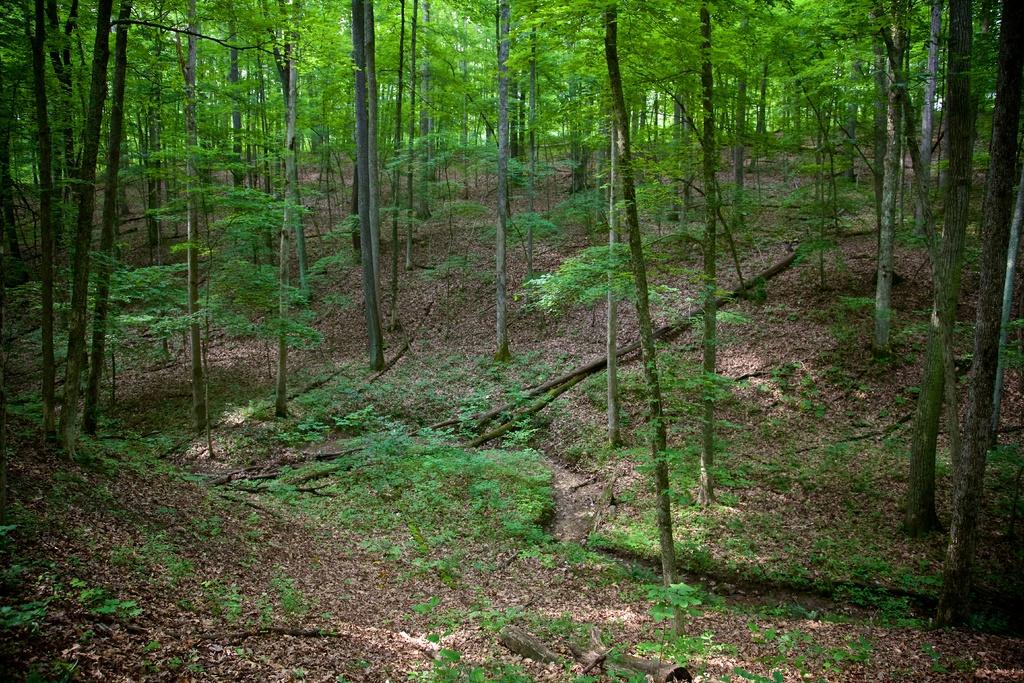What type of vegetation can be seen in the image? There are trees and plants in the image. What is visible beneath the vegetation in the image? The ground is visible in the image. Are there any objects placed on the ground in the image? Yes, there are objects on the ground in the image. What day of the week is depicted in the image? The image does not depict a specific day of the week; it only shows trees, plants, and the ground. Can you guide me to the nearest water source in the image? There is no information about water sources in the image; it only shows trees, plants, and the ground. 